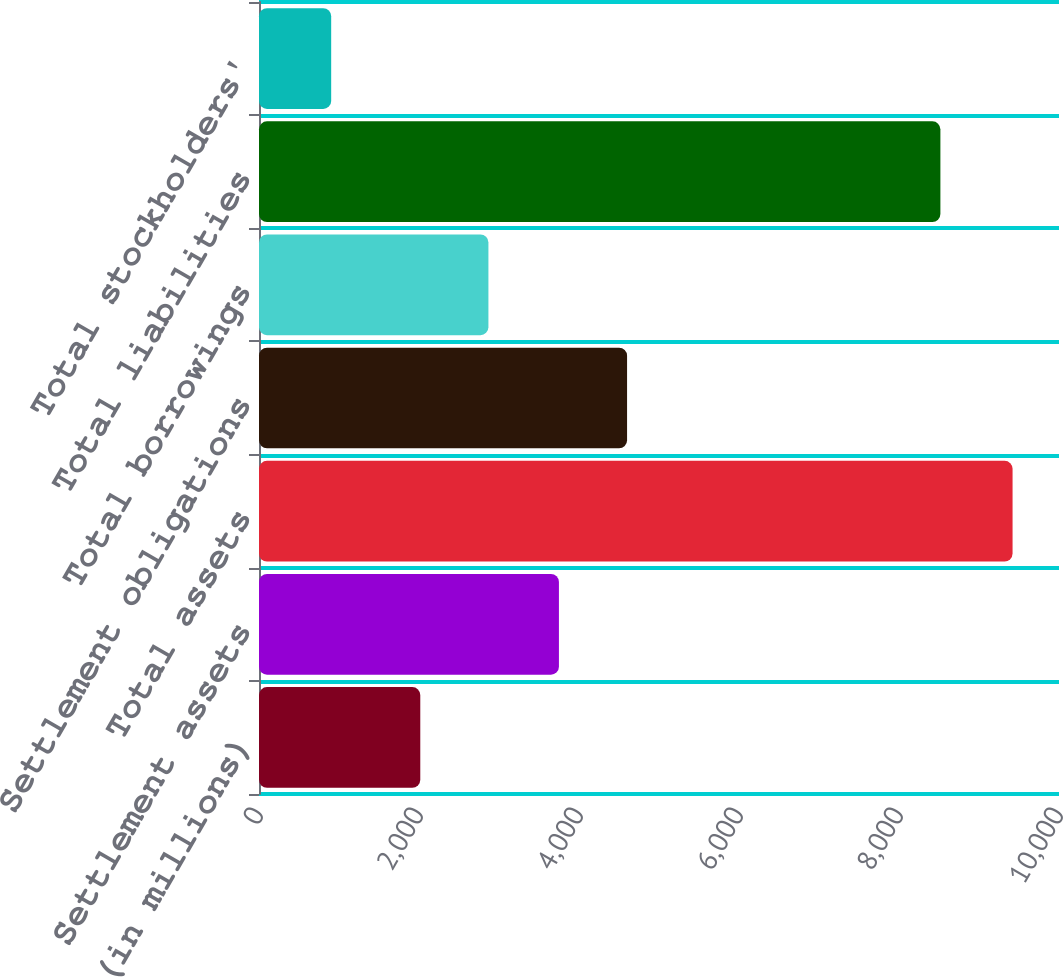<chart> <loc_0><loc_0><loc_500><loc_500><bar_chart><fcel>(in millions)<fcel>Settlement assets<fcel>Total assets<fcel>Settlement obligations<fcel>Total borrowings<fcel>Total liabilities<fcel>Total stockholders'<nl><fcel>2016<fcel>3749.1<fcel>9419.6<fcel>4600.84<fcel>2867.74<fcel>8517.4<fcel>902.2<nl></chart> 